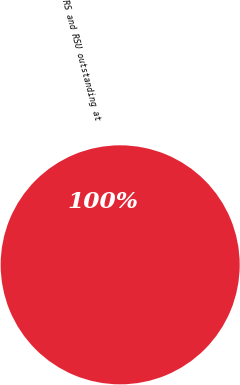Convert chart to OTSL. <chart><loc_0><loc_0><loc_500><loc_500><pie_chart><fcel>RS and RSU outstanding at<nl><fcel>100.0%<nl></chart> 